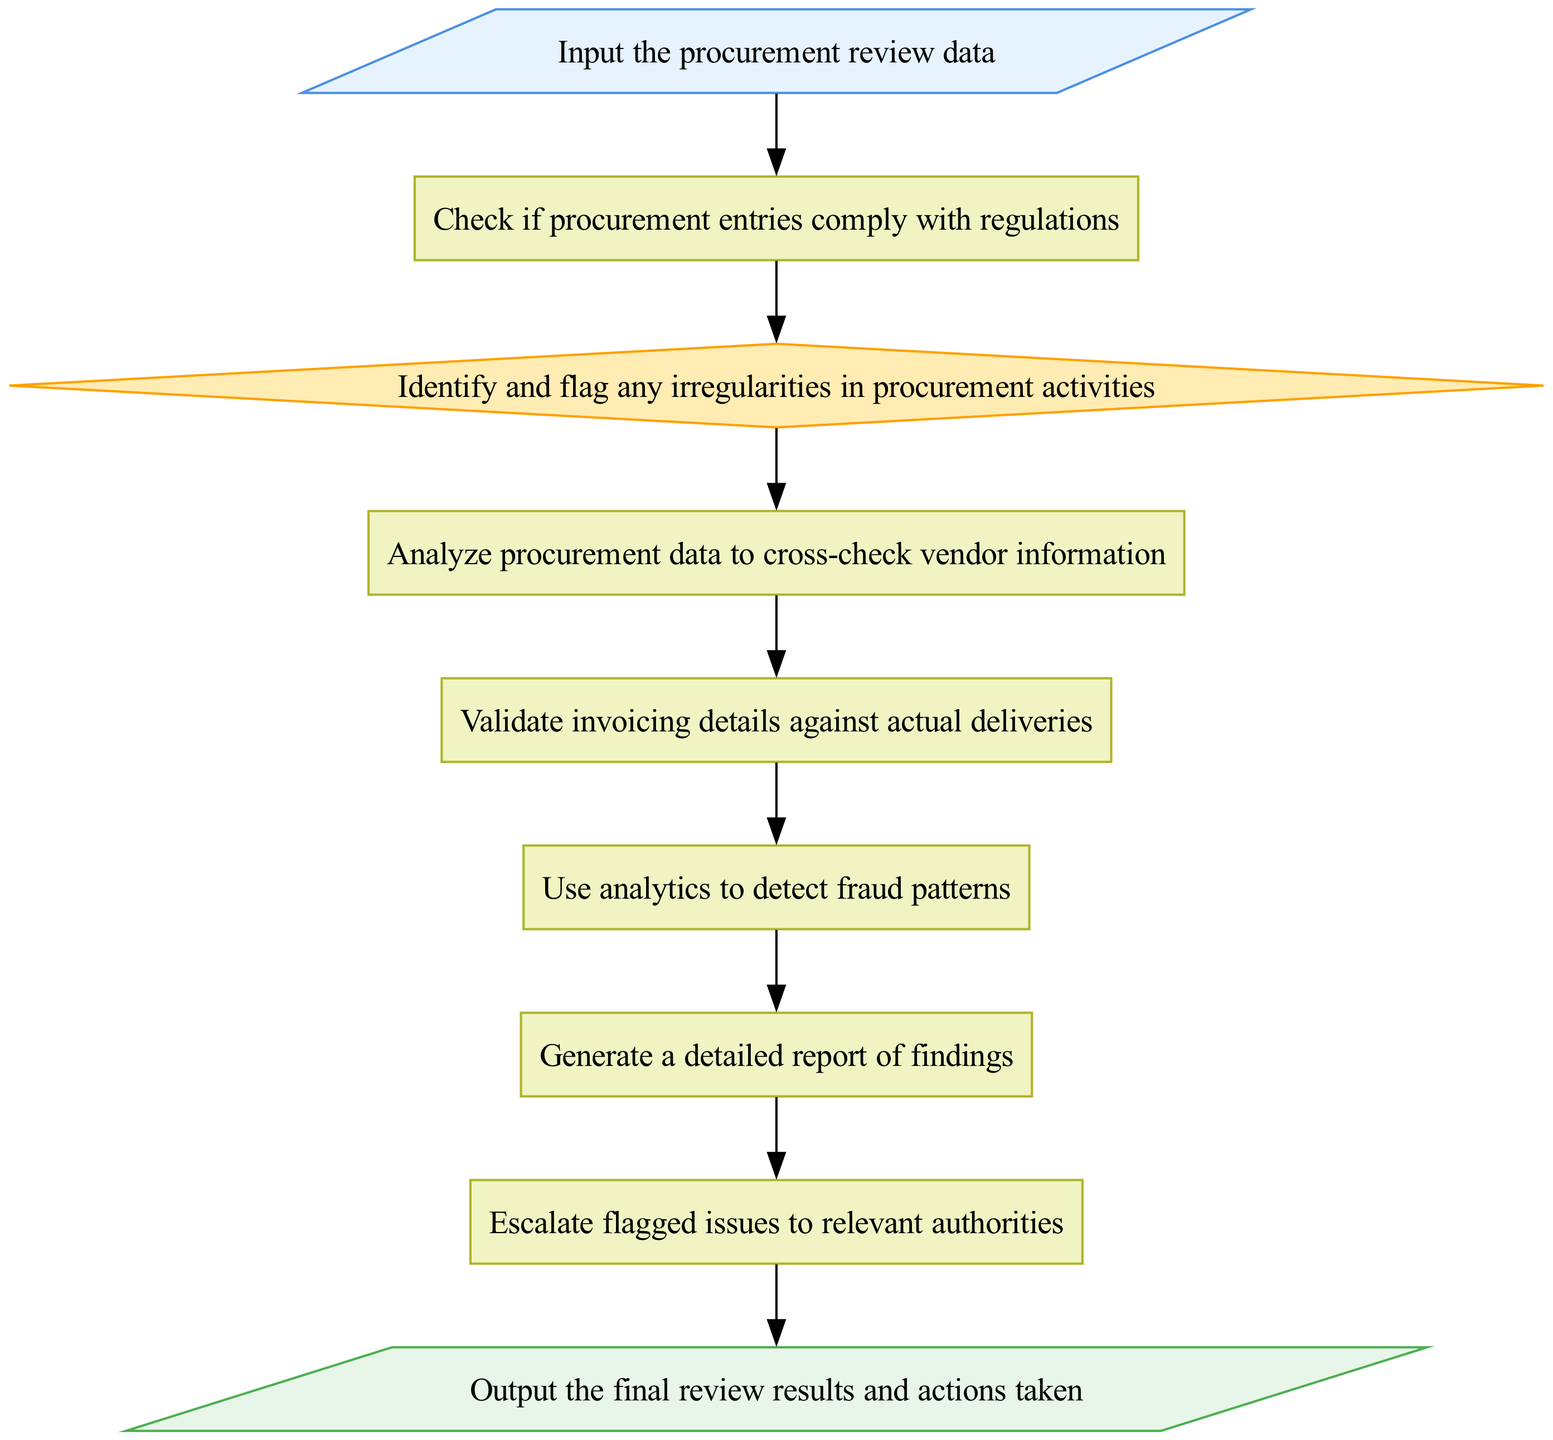what is the first step in the procurement review process? The first step in the procurement review process is to input the procurement review data. This is indicated as the initial element in the flowchart.
Answer: input the procurement review data how many decision nodes are in the diagram? There is one decision node in the diagram, which is labeled "flag irregularities." This can be counted from the elements listed in the flowchart.
Answer: one what comes after "check compliance"? After "check compliance," the next step is "flag irregularities." This is determined by following the flow arrows in the diagram.
Answer: flag irregularities which process analyzes procurement data? The process that analyzes procurement data is "analyze vendor data." This can be found by locating the relevant process in the flowchart.
Answer: analyze vendor data what is the final output of this process? The final output of this process is "output the final review results and actions taken." This is indicated as the last element in the flowchart and summarizes the end of the process.
Answer: output the final review results and actions taken describe the transition between "identify fraud patterns" and "generate report." The transition between "identify fraud patterns" and "generate report" is direct, indicating a sequential flow where findings from fraud detection lead directly to reporting. This is represented by an arrow drawn from the first process to the second process in the diagram.
Answer: direct transition what is required before escalating issues to authorities? Before escalating issues to authorities, the flagged irregularities must be addressed. This is evident from the flow of processes leading to the escalation step, which includes validation and analysis steps prior.
Answer: flagged irregularities how many processes are outlined in the diagram? There are five process nodes outlined in the diagram: "check compliance," "analyze vendor data," "validate invoices," "identify fraud patterns," and "generate report." These can be counted directly from the elements categorized as processes.
Answer: five 